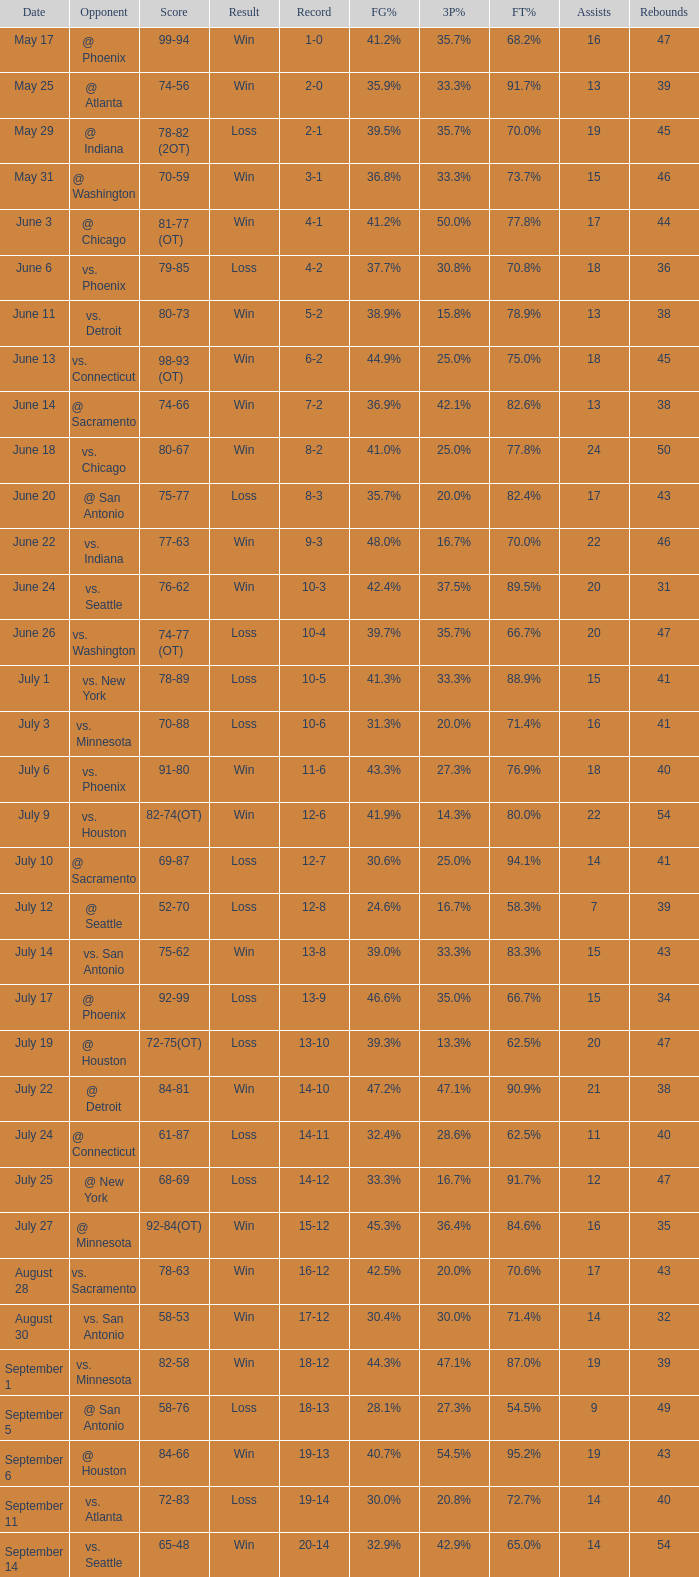What is the Opponent of the game with a Score of 74-66? @ Sacramento. 